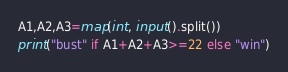Convert code to text. <code><loc_0><loc_0><loc_500><loc_500><_Python_>A1,A2,A3=map(int, input().split())
print("bust" if A1+A2+A3>=22 else "win")</code> 